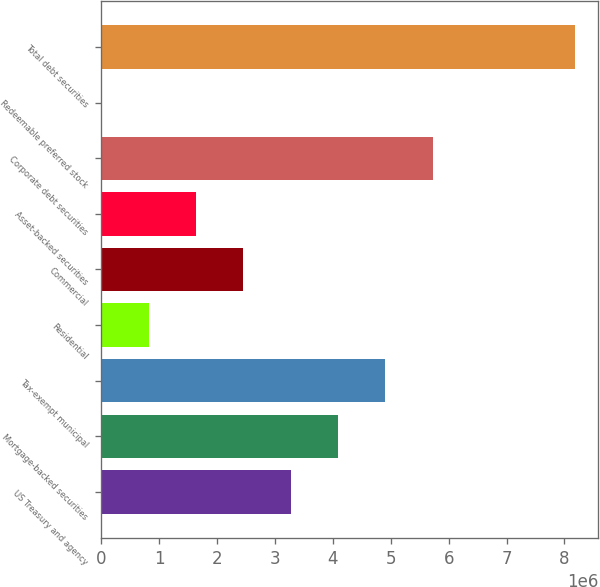Convert chart to OTSL. <chart><loc_0><loc_0><loc_500><loc_500><bar_chart><fcel>US Treasury and agency<fcel>Mortgage-backed securities<fcel>Tax-exempt municipal<fcel>Residential<fcel>Commercial<fcel>Asset-backed securities<fcel>Corporate debt securities<fcel>Redeemable preferred stock<fcel>Total debt securities<nl><fcel>3.27359e+06<fcel>4.09066e+06<fcel>4.90772e+06<fcel>822398<fcel>2.45653e+06<fcel>1.63946e+06<fcel>5.72479e+06<fcel>5333<fcel>8.17598e+06<nl></chart> 